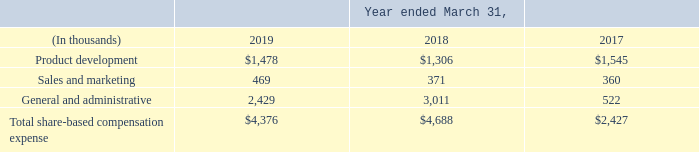14. Share-based Compensation
We may grant non-qualified stock options, incentive stock options, SSARs, restricted shares, and restricted share units under our shareholder-approved 2016 Stock Incentive Plan (the 2016 Plan) for up to 2.0 million common shares, plus 957,575 common shares, the number of shares that were remaining for grant under the 2011 Stock Incentive Plan (the 2011 Plan) as of the effective date of the 2016 Plan, plus the number of shares remaining for grant under the 2011 Plan that are forfeited, settled in cash, canceled or expired.
The maximum aggregate number of restricted shares or restricted share units that may be granted under the 2016 Plan is 1.25 million. We may distribute authorized but unissued shares or treasury shares to satisfy share option and appreciation right exercises or restricted share and performance share awards.
For stock options and SSARs, the exercise price must be set at least equal to the closing market price of our common shares on the date of grant. For stock options and SSARs, the exercise price must be stock options and SSARs. The maximum term of stock option and SSAR awards is seven years from the date of grant. Stock option and SSARs awards vest over a period established by the Compensation Committee of the Board of Directors.
SSARs may be granted in conjunction with, or independently from, stock option grants. SSARs granted in connection with a stock option are exercisable only to the extent that the stock option to which it relates is exercisable and the SSARs terminate upon the termination or exercise of the related stock option grants.
Restricted shares and restricted share units, whether time-vested or performance-based, may be issued at no cost or at a purchase price that may be below their fair market value, but are subject to forfeiture and restrictions on their sale or other transfer. Performance-based awards may be conditioned upon the attainment of specified performance objectives and other conditions, restrictions, and contingencies.
Restricted shares and restricted share units have the right to receive dividends, or dividend equivalents in the case of restricted share units, if any, upon vesting, subject to the same forfeiture provisions that apply to the underlying awards. Subject to certain exceptions set forth in the 2016 Plan, for awards to employees, no performance-based restricted shares or restricted share units shall be based on a restriction period of less than one year, and any time-based restricted shares or restricted share units shall have a minimum restriction period of three years.
We record compensation expense related to stock options, stock-settled stock appreciation rights, restricted shares, and performance shares granted to certain employees and non-employee directors based on the fair value of the awards on the grant date. The fair value of restricted share and performance share awards is based on the closing price of our common shares on the grant date.
The fair value of stock option and stock-settled appreciation right awards is estimated on the grant date using the Black-Scholes-Merton option pricing model, which includes assumptions regarding the risk-free interest rate, dividend yield, life of the award, and the volatility of our common shares.
The following table summarizes the share-based compensation expense for options, SSARs, restricted and performance awards included in the Consolidated Statements of Operations for fiscal 2019, 2018 and 2017:
What is the exercise price for stock options and SSARs? Set at least equal to the closing market price of our common shares on the date of grant. What was the Share-based Compensation for product development in 2019?
Answer scale should be: thousand. $1,478. What was the Share-based Compensation for sales and marketing in 2019?
Answer scale should be: thousand. 469. What was the increase / (decrease) in the product development Share-based Compensation from 2018 to 2019?
Answer scale should be: thousand. 1,478 - 1,306
Answer: 172. What was the average sales and marketing Share-based Compensation for 2017-2019?
Answer scale should be: thousand. (469 + 371 + 360) / 3
Answer: 400. What was the average general and administrative Share-based Compensation for 2017-2019?
Answer scale should be: thousand. (2,429 + 3,011 + 522) / 3
Answer: 1987.33. 